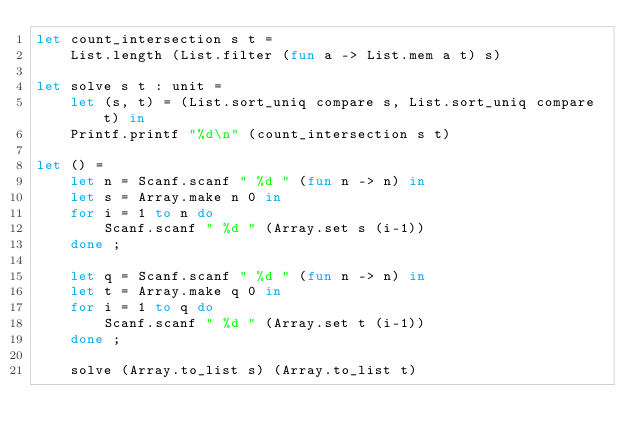Convert code to text. <code><loc_0><loc_0><loc_500><loc_500><_OCaml_>let count_intersection s t =
    List.length (List.filter (fun a -> List.mem a t) s)

let solve s t : unit =
    let (s, t) = (List.sort_uniq compare s, List.sort_uniq compare t) in
    Printf.printf "%d\n" (count_intersection s t)

let () =
    let n = Scanf.scanf " %d " (fun n -> n) in
    let s = Array.make n 0 in
    for i = 1 to n do
        Scanf.scanf " %d " (Array.set s (i-1))
    done ;

    let q = Scanf.scanf " %d " (fun n -> n) in
    let t = Array.make q 0 in
    for i = 1 to q do
        Scanf.scanf " %d " (Array.set t (i-1))
    done ;

    solve (Array.to_list s) (Array.to_list t)</code> 